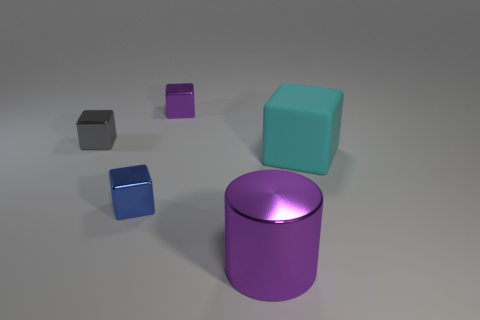Subtract all blue blocks. Subtract all cyan balls. How many blocks are left? 3 Add 3 large red metal spheres. How many objects exist? 8 Subtract all cubes. How many objects are left? 1 Add 5 large things. How many large things are left? 7 Add 4 matte things. How many matte things exist? 5 Subtract 0 gray cylinders. How many objects are left? 5 Subtract all tiny gray metal objects. Subtract all cyan metal objects. How many objects are left? 4 